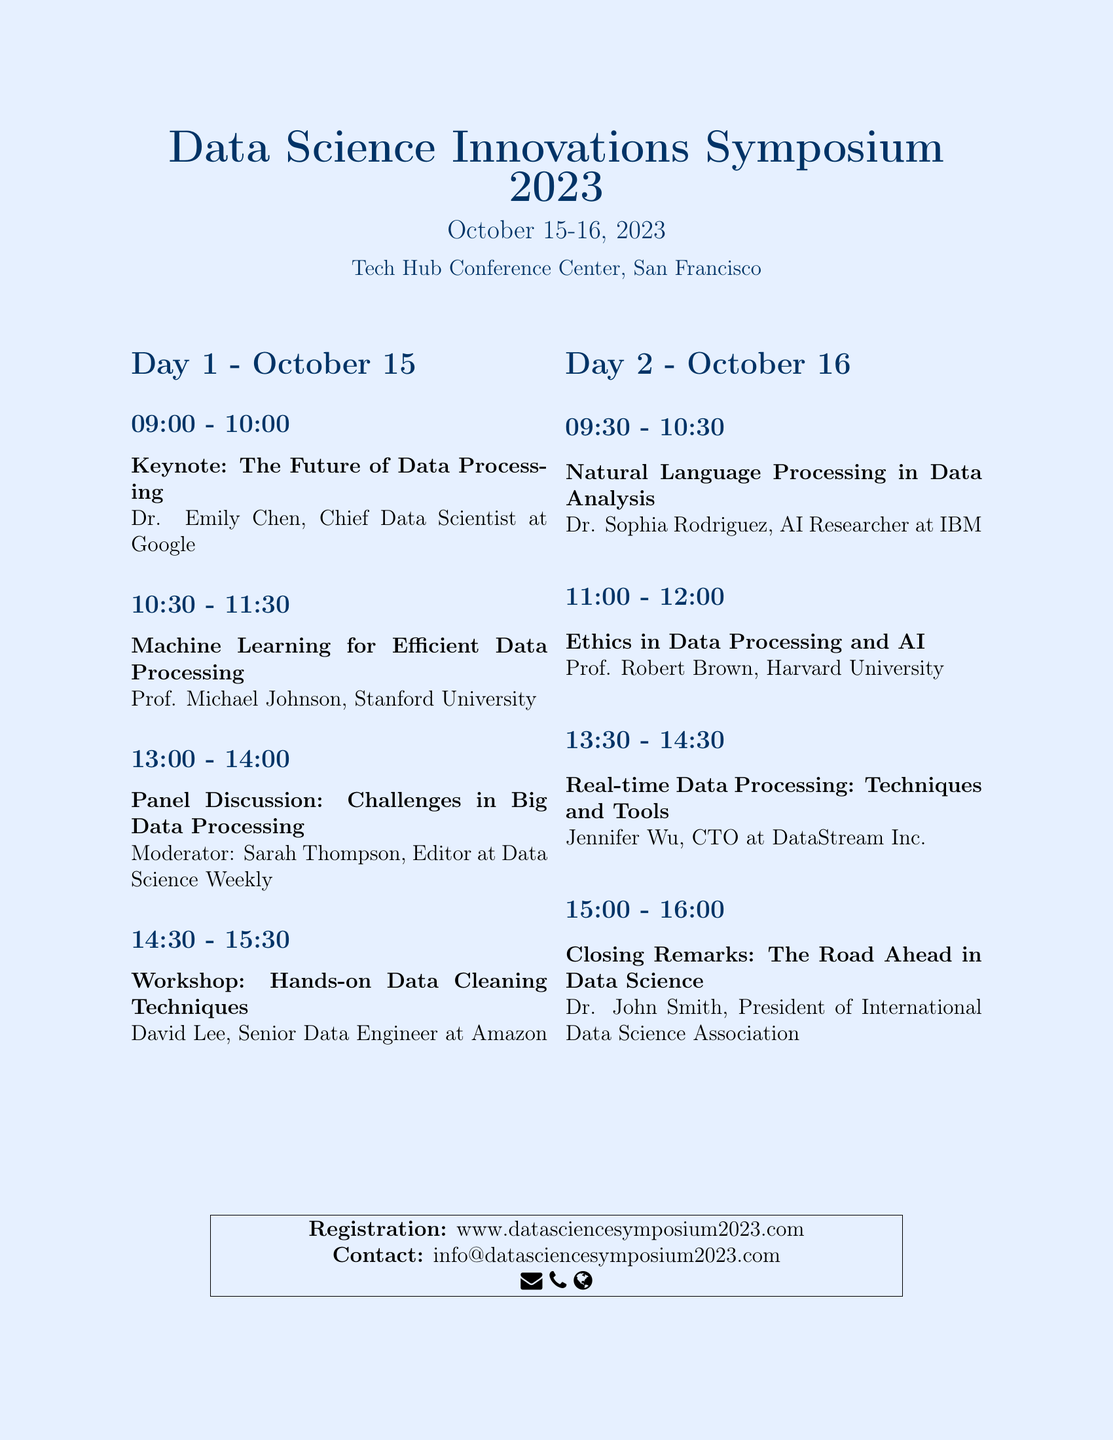What are the dates of the symposium? The dates are explicitly stated in the document as October 15-16, 2023.
Answer: October 15-16, 2023 Who is the keynote speaker? The keynote speaker is indicated in the schedule as Dr. Emily Chen, Chief Data Scientist at Google.
Answer: Dr. Emily Chen What time does the "Machine Learning for Efficient Data Processing" session start? The start time is listed in the document for the specific session on Day 1.
Answer: 10:30 What is the topic of the panel discussion? The topic is provided in the agenda under Day 1, and it covers challenges related to big data.
Answer: Challenges in Big Data Processing How many sessions are there on Day 2? By counting the sessions listed under Day 2, we can determine the total number of sessions.
Answer: Four Who is moderating the panel discussion? The moderator's name is found in the document under the panel discussion details.
Answer: Sarah Thompson What is the focus of the workshop on Day 1? The workshop topic is clearly articulated in the agenda.
Answer: Hands-on Data Cleaning Techniques What organization is Dr. John Smith associated with? Dr. John Smith's affiliation is stated in the closing remarks section.
Answer: International Data Science Association 